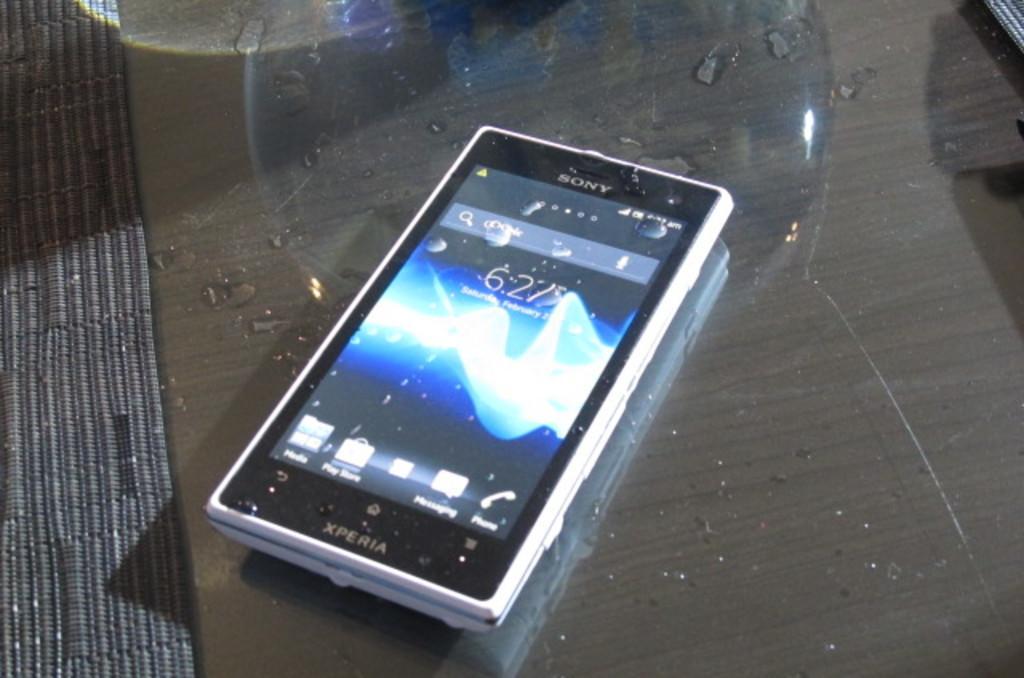Can you describe this image briefly? It is a mobile phone of Sony company on a glass table. 